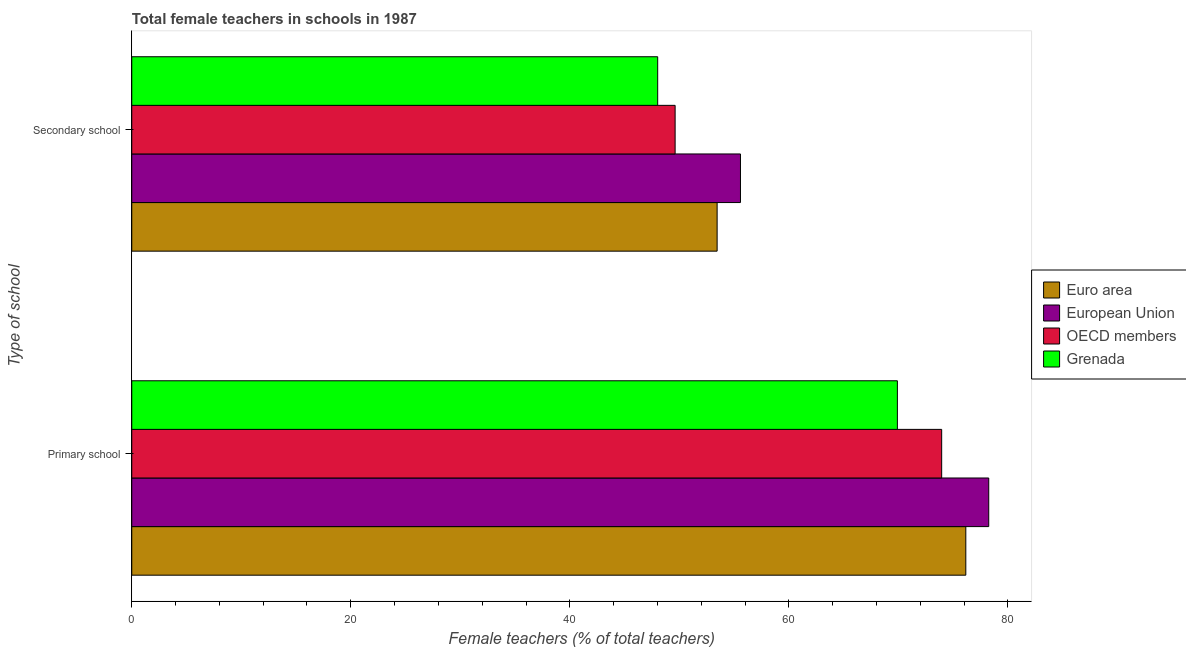How many different coloured bars are there?
Your answer should be very brief. 4. Are the number of bars per tick equal to the number of legend labels?
Keep it short and to the point. Yes. What is the label of the 2nd group of bars from the top?
Offer a terse response. Primary school. What is the percentage of female teachers in primary schools in European Union?
Keep it short and to the point. 78.26. Across all countries, what is the maximum percentage of female teachers in secondary schools?
Provide a short and direct response. 55.58. Across all countries, what is the minimum percentage of female teachers in primary schools?
Provide a short and direct response. 69.91. In which country was the percentage of female teachers in secondary schools maximum?
Your answer should be very brief. European Union. In which country was the percentage of female teachers in primary schools minimum?
Give a very brief answer. Grenada. What is the total percentage of female teachers in secondary schools in the graph?
Keep it short and to the point. 206.68. What is the difference between the percentage of female teachers in secondary schools in European Union and that in Grenada?
Give a very brief answer. 7.56. What is the difference between the percentage of female teachers in secondary schools in European Union and the percentage of female teachers in primary schools in Grenada?
Provide a short and direct response. -14.33. What is the average percentage of female teachers in primary schools per country?
Make the answer very short. 74.57. What is the difference between the percentage of female teachers in secondary schools and percentage of female teachers in primary schools in Euro area?
Provide a succinct answer. -22.71. What is the ratio of the percentage of female teachers in primary schools in OECD members to that in European Union?
Offer a very short reply. 0.95. Is the percentage of female teachers in secondary schools in European Union less than that in Euro area?
Ensure brevity in your answer.  No. In how many countries, is the percentage of female teachers in primary schools greater than the average percentage of female teachers in primary schools taken over all countries?
Provide a short and direct response. 2. What does the 1st bar from the top in Secondary school represents?
Your response must be concise. Grenada. What does the 4th bar from the bottom in Primary school represents?
Offer a terse response. Grenada. Are the values on the major ticks of X-axis written in scientific E-notation?
Offer a very short reply. No. Does the graph contain any zero values?
Your answer should be compact. No. Does the graph contain grids?
Provide a succinct answer. No. Where does the legend appear in the graph?
Your response must be concise. Center right. How many legend labels are there?
Provide a succinct answer. 4. What is the title of the graph?
Offer a terse response. Total female teachers in schools in 1987. What is the label or title of the X-axis?
Make the answer very short. Female teachers (% of total teachers). What is the label or title of the Y-axis?
Offer a very short reply. Type of school. What is the Female teachers (% of total teachers) of Euro area in Primary school?
Offer a terse response. 76.16. What is the Female teachers (% of total teachers) in European Union in Primary school?
Ensure brevity in your answer.  78.26. What is the Female teachers (% of total teachers) of OECD members in Primary school?
Your answer should be compact. 73.96. What is the Female teachers (% of total teachers) in Grenada in Primary school?
Provide a succinct answer. 69.91. What is the Female teachers (% of total teachers) of Euro area in Secondary school?
Give a very brief answer. 53.45. What is the Female teachers (% of total teachers) of European Union in Secondary school?
Provide a short and direct response. 55.58. What is the Female teachers (% of total teachers) of OECD members in Secondary school?
Make the answer very short. 49.62. What is the Female teachers (% of total teachers) in Grenada in Secondary school?
Provide a short and direct response. 48.03. Across all Type of school, what is the maximum Female teachers (% of total teachers) in Euro area?
Keep it short and to the point. 76.16. Across all Type of school, what is the maximum Female teachers (% of total teachers) of European Union?
Keep it short and to the point. 78.26. Across all Type of school, what is the maximum Female teachers (% of total teachers) in OECD members?
Your answer should be compact. 73.96. Across all Type of school, what is the maximum Female teachers (% of total teachers) in Grenada?
Your answer should be very brief. 69.91. Across all Type of school, what is the minimum Female teachers (% of total teachers) in Euro area?
Your answer should be compact. 53.45. Across all Type of school, what is the minimum Female teachers (% of total teachers) in European Union?
Make the answer very short. 55.58. Across all Type of school, what is the minimum Female teachers (% of total teachers) of OECD members?
Your answer should be very brief. 49.62. Across all Type of school, what is the minimum Female teachers (% of total teachers) in Grenada?
Ensure brevity in your answer.  48.03. What is the total Female teachers (% of total teachers) of Euro area in the graph?
Your answer should be compact. 129.62. What is the total Female teachers (% of total teachers) of European Union in the graph?
Offer a terse response. 133.84. What is the total Female teachers (% of total teachers) of OECD members in the graph?
Offer a very short reply. 123.58. What is the total Female teachers (% of total teachers) in Grenada in the graph?
Give a very brief answer. 117.94. What is the difference between the Female teachers (% of total teachers) in Euro area in Primary school and that in Secondary school?
Your answer should be very brief. 22.71. What is the difference between the Female teachers (% of total teachers) of European Union in Primary school and that in Secondary school?
Provide a succinct answer. 22.67. What is the difference between the Female teachers (% of total teachers) of OECD members in Primary school and that in Secondary school?
Your answer should be very brief. 24.34. What is the difference between the Female teachers (% of total teachers) in Grenada in Primary school and that in Secondary school?
Provide a succinct answer. 21.89. What is the difference between the Female teachers (% of total teachers) of Euro area in Primary school and the Female teachers (% of total teachers) of European Union in Secondary school?
Give a very brief answer. 20.58. What is the difference between the Female teachers (% of total teachers) in Euro area in Primary school and the Female teachers (% of total teachers) in OECD members in Secondary school?
Keep it short and to the point. 26.55. What is the difference between the Female teachers (% of total teachers) in Euro area in Primary school and the Female teachers (% of total teachers) in Grenada in Secondary school?
Ensure brevity in your answer.  28.14. What is the difference between the Female teachers (% of total teachers) in European Union in Primary school and the Female teachers (% of total teachers) in OECD members in Secondary school?
Provide a short and direct response. 28.64. What is the difference between the Female teachers (% of total teachers) in European Union in Primary school and the Female teachers (% of total teachers) in Grenada in Secondary school?
Make the answer very short. 30.23. What is the difference between the Female teachers (% of total teachers) of OECD members in Primary school and the Female teachers (% of total teachers) of Grenada in Secondary school?
Your response must be concise. 25.93. What is the average Female teachers (% of total teachers) of Euro area per Type of school?
Offer a very short reply. 64.81. What is the average Female teachers (% of total teachers) of European Union per Type of school?
Your answer should be compact. 66.92. What is the average Female teachers (% of total teachers) of OECD members per Type of school?
Offer a very short reply. 61.79. What is the average Female teachers (% of total teachers) in Grenada per Type of school?
Give a very brief answer. 58.97. What is the difference between the Female teachers (% of total teachers) in Euro area and Female teachers (% of total teachers) in European Union in Primary school?
Your answer should be very brief. -2.09. What is the difference between the Female teachers (% of total teachers) of Euro area and Female teachers (% of total teachers) of OECD members in Primary school?
Ensure brevity in your answer.  2.21. What is the difference between the Female teachers (% of total teachers) in Euro area and Female teachers (% of total teachers) in Grenada in Primary school?
Your answer should be compact. 6.25. What is the difference between the Female teachers (% of total teachers) of European Union and Female teachers (% of total teachers) of OECD members in Primary school?
Offer a terse response. 4.3. What is the difference between the Female teachers (% of total teachers) in European Union and Female teachers (% of total teachers) in Grenada in Primary school?
Your answer should be very brief. 8.34. What is the difference between the Female teachers (% of total teachers) of OECD members and Female teachers (% of total teachers) of Grenada in Primary school?
Provide a short and direct response. 4.04. What is the difference between the Female teachers (% of total teachers) in Euro area and Female teachers (% of total teachers) in European Union in Secondary school?
Give a very brief answer. -2.13. What is the difference between the Female teachers (% of total teachers) in Euro area and Female teachers (% of total teachers) in OECD members in Secondary school?
Provide a short and direct response. 3.84. What is the difference between the Female teachers (% of total teachers) in Euro area and Female teachers (% of total teachers) in Grenada in Secondary school?
Your answer should be compact. 5.43. What is the difference between the Female teachers (% of total teachers) in European Union and Female teachers (% of total teachers) in OECD members in Secondary school?
Offer a very short reply. 5.97. What is the difference between the Female teachers (% of total teachers) of European Union and Female teachers (% of total teachers) of Grenada in Secondary school?
Provide a succinct answer. 7.56. What is the difference between the Female teachers (% of total teachers) of OECD members and Female teachers (% of total teachers) of Grenada in Secondary school?
Your answer should be compact. 1.59. What is the ratio of the Female teachers (% of total teachers) in Euro area in Primary school to that in Secondary school?
Offer a very short reply. 1.42. What is the ratio of the Female teachers (% of total teachers) in European Union in Primary school to that in Secondary school?
Give a very brief answer. 1.41. What is the ratio of the Female teachers (% of total teachers) in OECD members in Primary school to that in Secondary school?
Your answer should be very brief. 1.49. What is the ratio of the Female teachers (% of total teachers) of Grenada in Primary school to that in Secondary school?
Your response must be concise. 1.46. What is the difference between the highest and the second highest Female teachers (% of total teachers) of Euro area?
Ensure brevity in your answer.  22.71. What is the difference between the highest and the second highest Female teachers (% of total teachers) of European Union?
Provide a short and direct response. 22.67. What is the difference between the highest and the second highest Female teachers (% of total teachers) of OECD members?
Ensure brevity in your answer.  24.34. What is the difference between the highest and the second highest Female teachers (% of total teachers) of Grenada?
Provide a short and direct response. 21.89. What is the difference between the highest and the lowest Female teachers (% of total teachers) in Euro area?
Offer a very short reply. 22.71. What is the difference between the highest and the lowest Female teachers (% of total teachers) of European Union?
Your answer should be very brief. 22.67. What is the difference between the highest and the lowest Female teachers (% of total teachers) of OECD members?
Make the answer very short. 24.34. What is the difference between the highest and the lowest Female teachers (% of total teachers) of Grenada?
Your response must be concise. 21.89. 